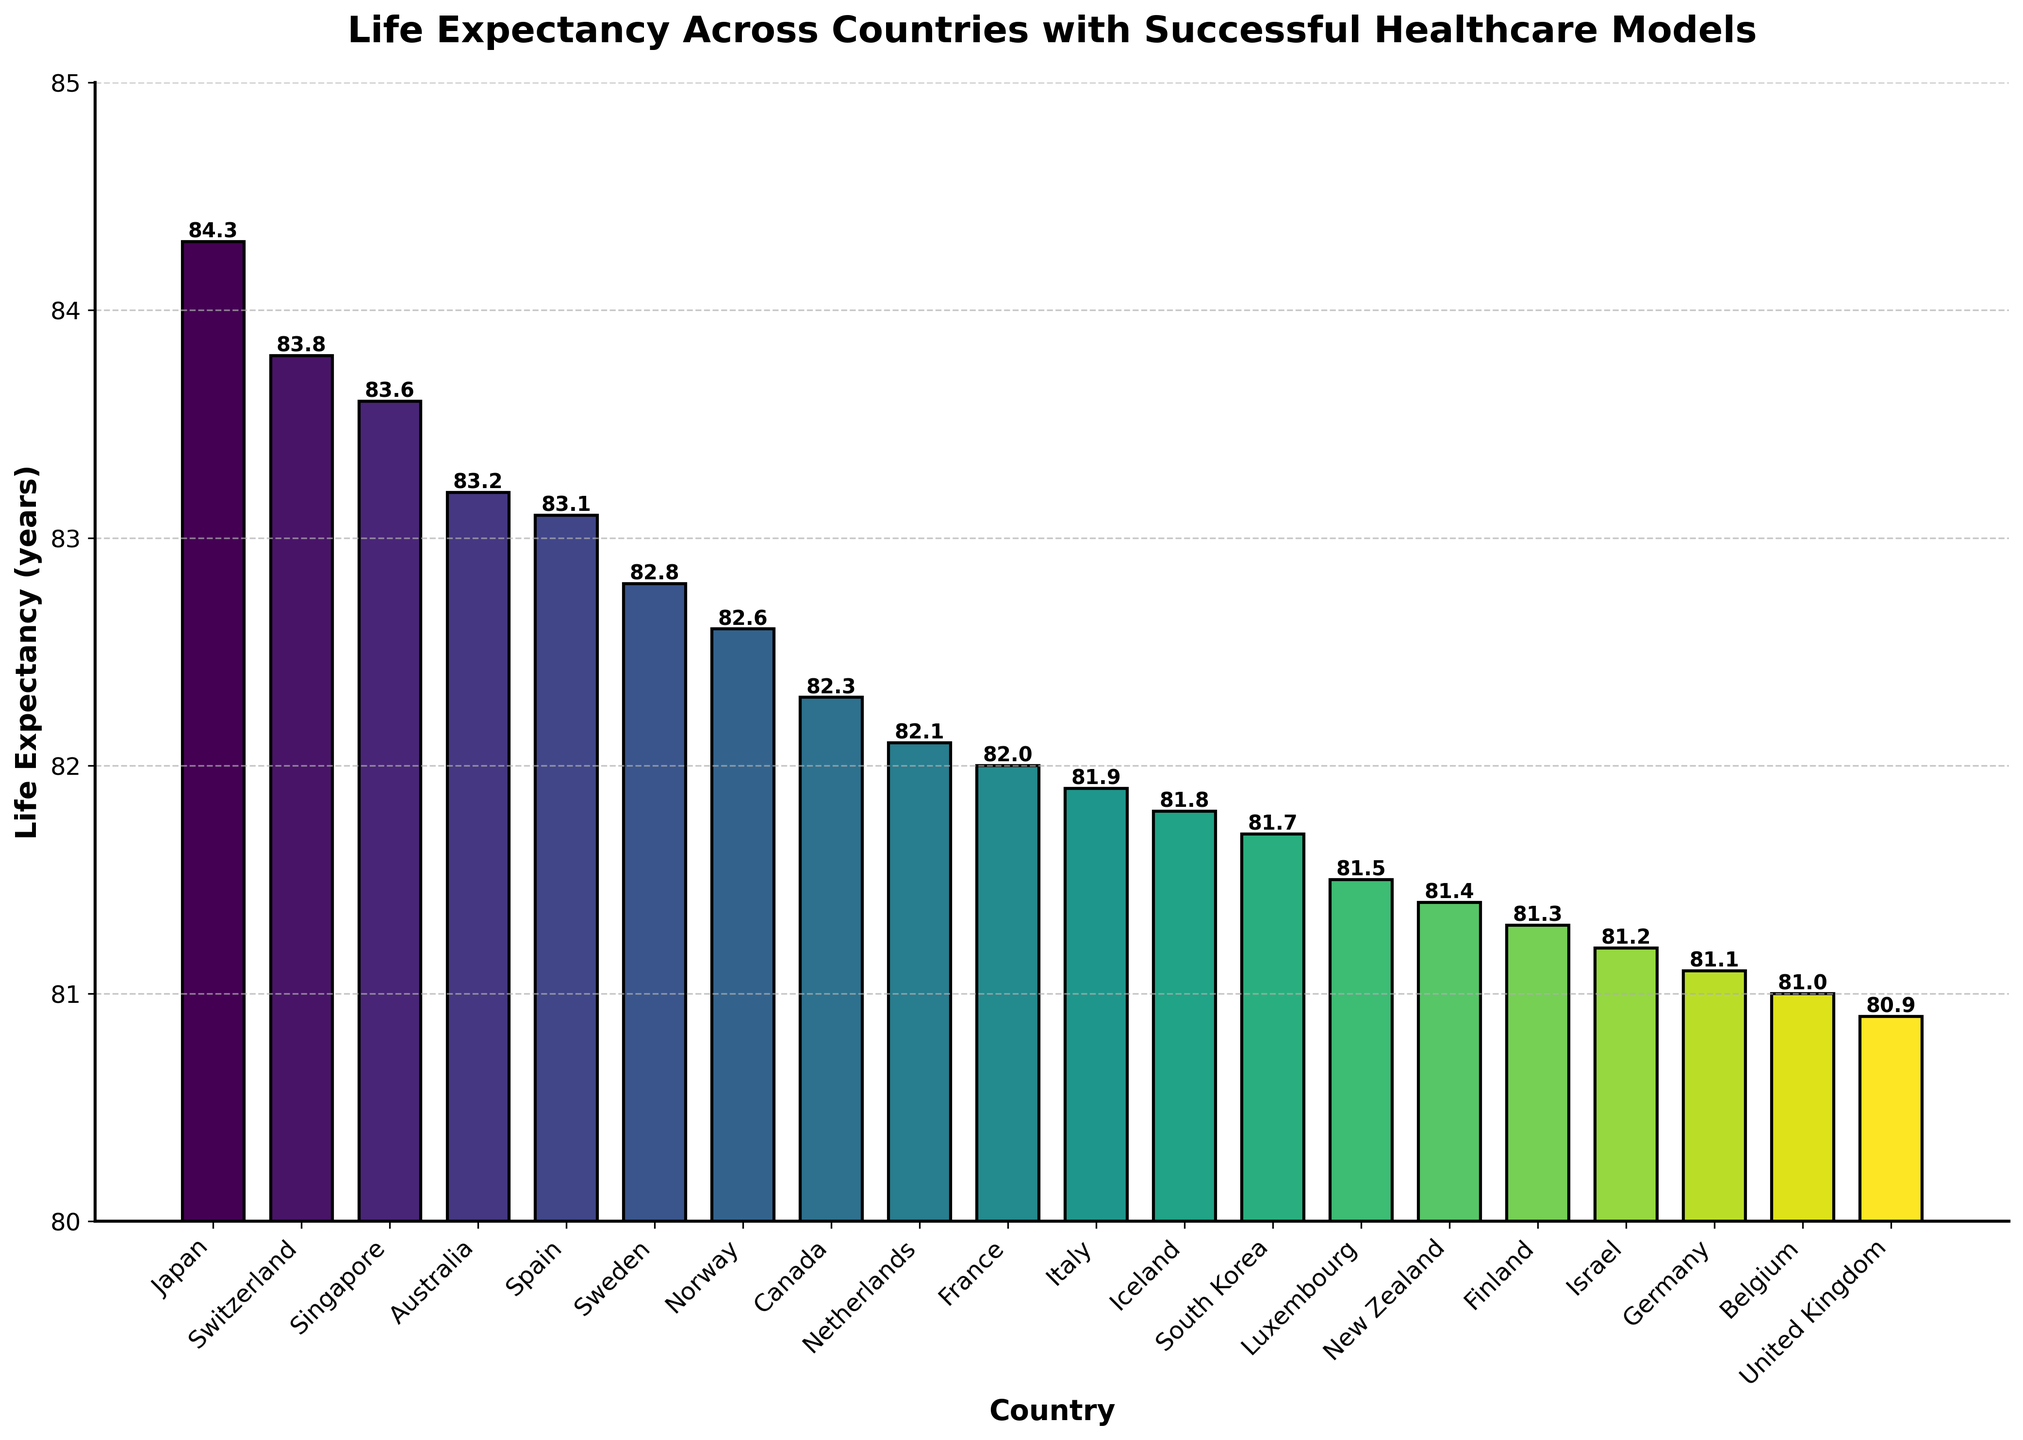Which country has the highest life expectancy according to the chart? By looking at the height of the bars, we can see that Japan has the tallest bar with a life expectancy of 84.3 years, followed by Switzerland and Singapore.
Answer: Japan What is the difference in life expectancy between the country with the highest and lowest values in the chart? The country with the highest life expectancy is Japan at 84.3 years, and the country with the lowest is the United Kingdom at 80.9 years. The difference is calculated as 84.3 - 80.9.
Answer: 3.4 years Which three countries have the closest life expectancy values and what are their values? Observing the chart, we can see that Germany (81.1), Belgium (81.0), and the United Kingdom (80.9) have very close life expectancies, with a difference of only 0.2 years between the highest and lowest of these three values.
Answer: Germany (81.1), Belgium (81.0), United Kingdom (80.9) What is the average life expectancy of the countries listed in the chart? To find the average, sum all life expectancy values and divide by the total number of countries. The sum is 1646.4 years and there are 20 countries, so the average is 1646.4 / 20.
Answer: 82.3 years How many countries have a life expectancy greater than 82 years? From the chart, we observe that Japan, Switzerland, Singapore, Australia, Spain, Sweden, and Norway all exceed 82 years. Count these bars to get the total.
Answer: 7 countries Which country does the bar with the darkest color represent, and what is its life expectancy? The darkest color in the gradient (viridis) scheme will represent the lowest value in the chart. In this case, the country is the United Kingdom with a life expectancy of 80.9 years.
Answer: United Kingdom, 80.9 years Among the countries listed, does New Zealand have a higher or lower life expectancy than Finland? By how much? By comparing the heights of their bars, New Zealand's life expectancy is 81.4 years, and Finland's is 81.3 years. The difference is 81.4 - 81.3.
Answer: Higher by 0.1 years If we grouped the countries by life expectancy intervals of 1 year (between 80-81, 81-82, 82-83, etc.), which interval has the most countries, and how many countries are in that interval? The intervals will be as follows: 80-81: 0 countries, 81-82: 9 countries, 82-83: 5 countries, 83-84: 4 countries, 84-85: 1 country. The interval 81-82 has the most countries.
Answer: 81-82 interval, 9 countries What percentage of the countries listed have a life expectancy below 82 years? There are 8 countries with life expectancy below 82 years out of a total of 20 countries. The percentage is calculated as (8 / 20) * 100.
Answer: 40% 